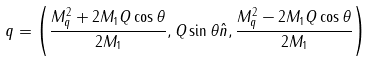<formula> <loc_0><loc_0><loc_500><loc_500>q = \left ( \frac { M ^ { 2 } _ { q } + 2 M _ { 1 } Q \cos \theta } { 2 M _ { 1 } } , Q \sin \theta \hat { n } , \frac { M ^ { 2 } _ { q } - 2 M _ { 1 } Q \cos \theta } { 2 M _ { 1 } } \right )</formula> 